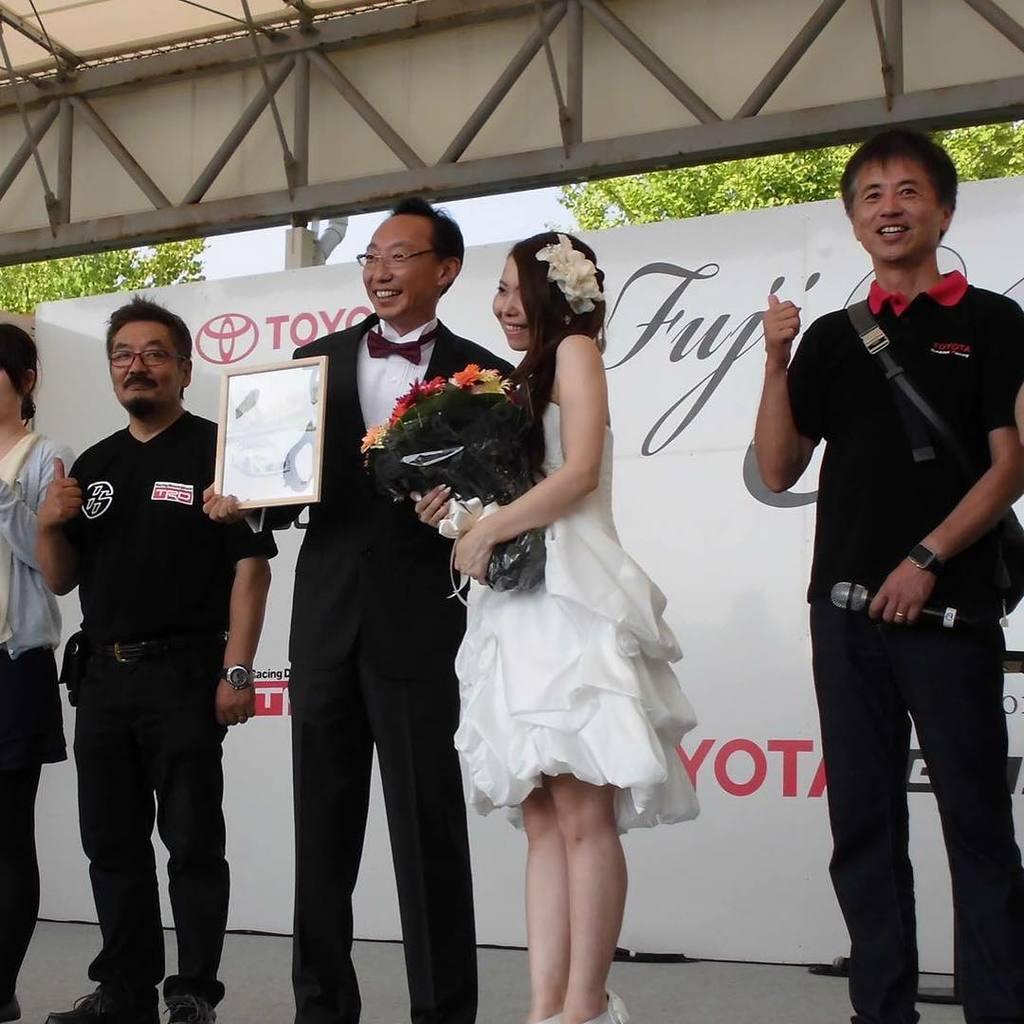How would you summarize this image in a sentence or two? In the foreground of the picture there are people standing. In the center of the picture the woman is holding a bouquet and the man is holding a frame. In the center of the picture there is a banner. At the top there are iron frames. In the background there are trees. 